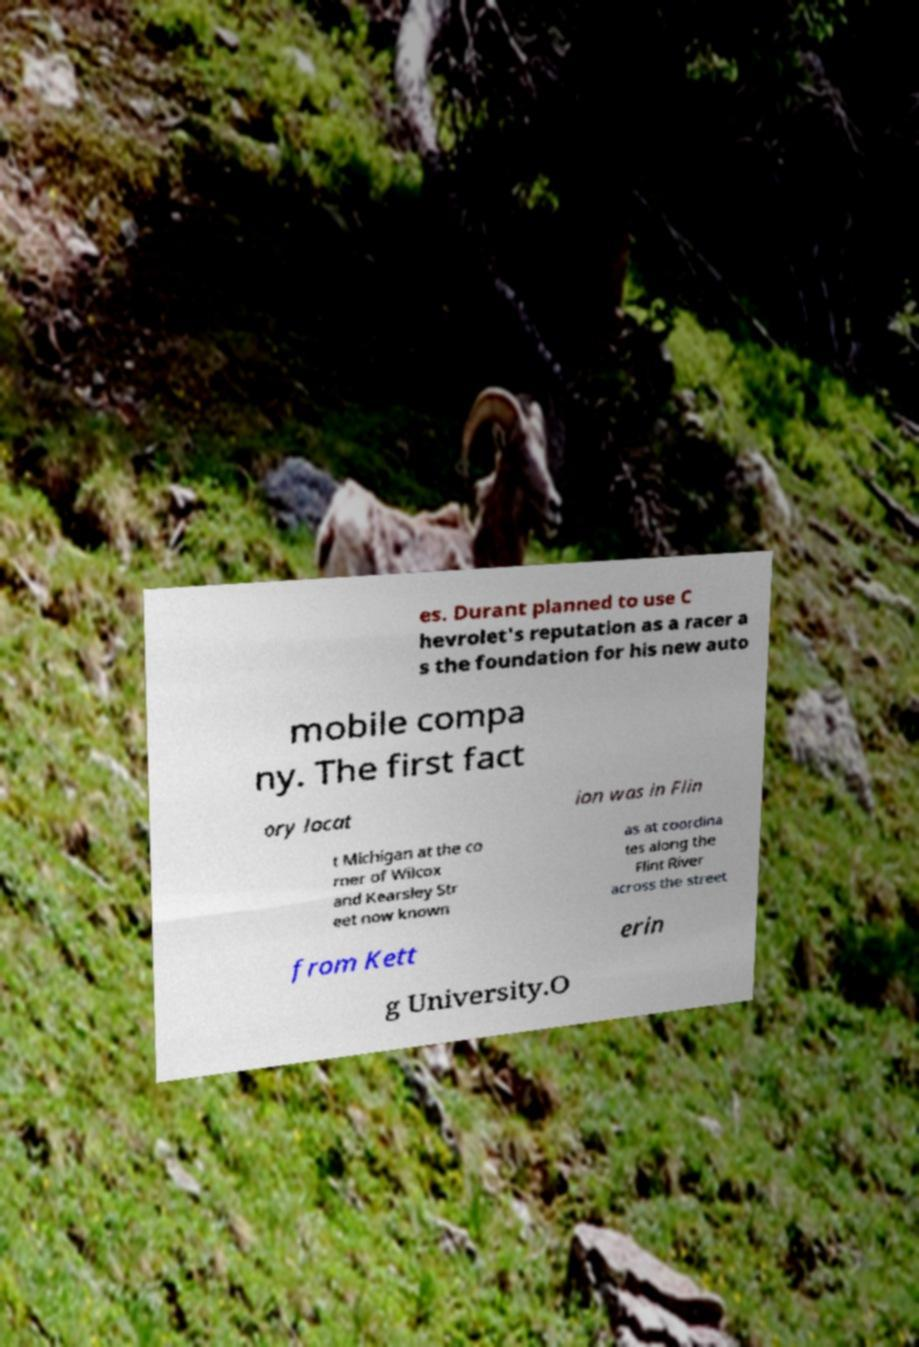There's text embedded in this image that I need extracted. Can you transcribe it verbatim? es. Durant planned to use C hevrolet's reputation as a racer a s the foundation for his new auto mobile compa ny. The first fact ory locat ion was in Flin t Michigan at the co rner of Wilcox and Kearsley Str eet now known as at coordina tes along the Flint River across the street from Kett erin g University.O 